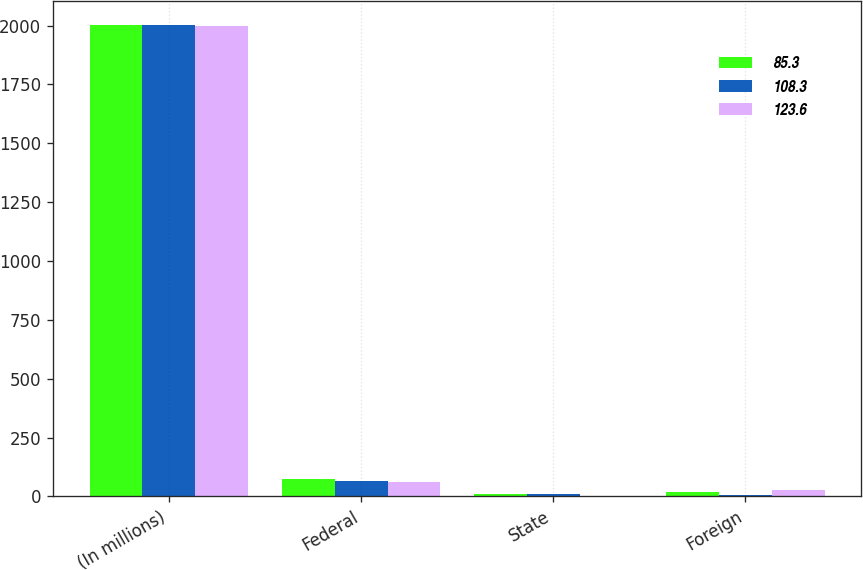Convert chart. <chart><loc_0><loc_0><loc_500><loc_500><stacked_bar_chart><ecel><fcel>(In millions)<fcel>Federal<fcel>State<fcel>Foreign<nl><fcel>85.3<fcel>2002<fcel>71.9<fcel>10<fcel>20.6<nl><fcel>108.3<fcel>2001<fcel>65.7<fcel>8.4<fcel>5.7<nl><fcel>123.6<fcel>2000<fcel>60.6<fcel>2.9<fcel>25.6<nl></chart> 